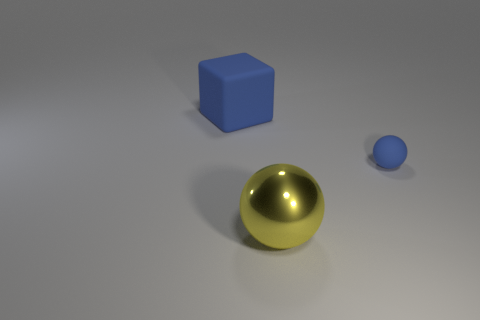What shape is the big blue object?
Your answer should be very brief. Cube. What is the shape of the blue rubber object behind the blue matte thing that is in front of the large rubber block that is behind the big sphere?
Your answer should be very brief. Cube. There is a thing that is both behind the large shiny thing and right of the large cube; what is its size?
Offer a very short reply. Small. What is the shape of the thing that is both on the left side of the small blue matte thing and behind the metal sphere?
Your response must be concise. Cube. Is the color of the large object to the left of the yellow metal sphere the same as the metal sphere?
Offer a very short reply. No. There is a large block that is the same color as the tiny object; what is its material?
Keep it short and to the point. Rubber. What number of rubber things are the same color as the rubber sphere?
Offer a very short reply. 1. Do the large matte thing to the left of the tiny matte thing and the big shiny object have the same shape?
Keep it short and to the point. No. Is the number of large blue rubber objects that are in front of the metallic sphere less than the number of big metallic balls that are to the right of the big blue object?
Provide a short and direct response. Yes. There is a large object in front of the rubber ball; what is its material?
Your answer should be compact. Metal. 